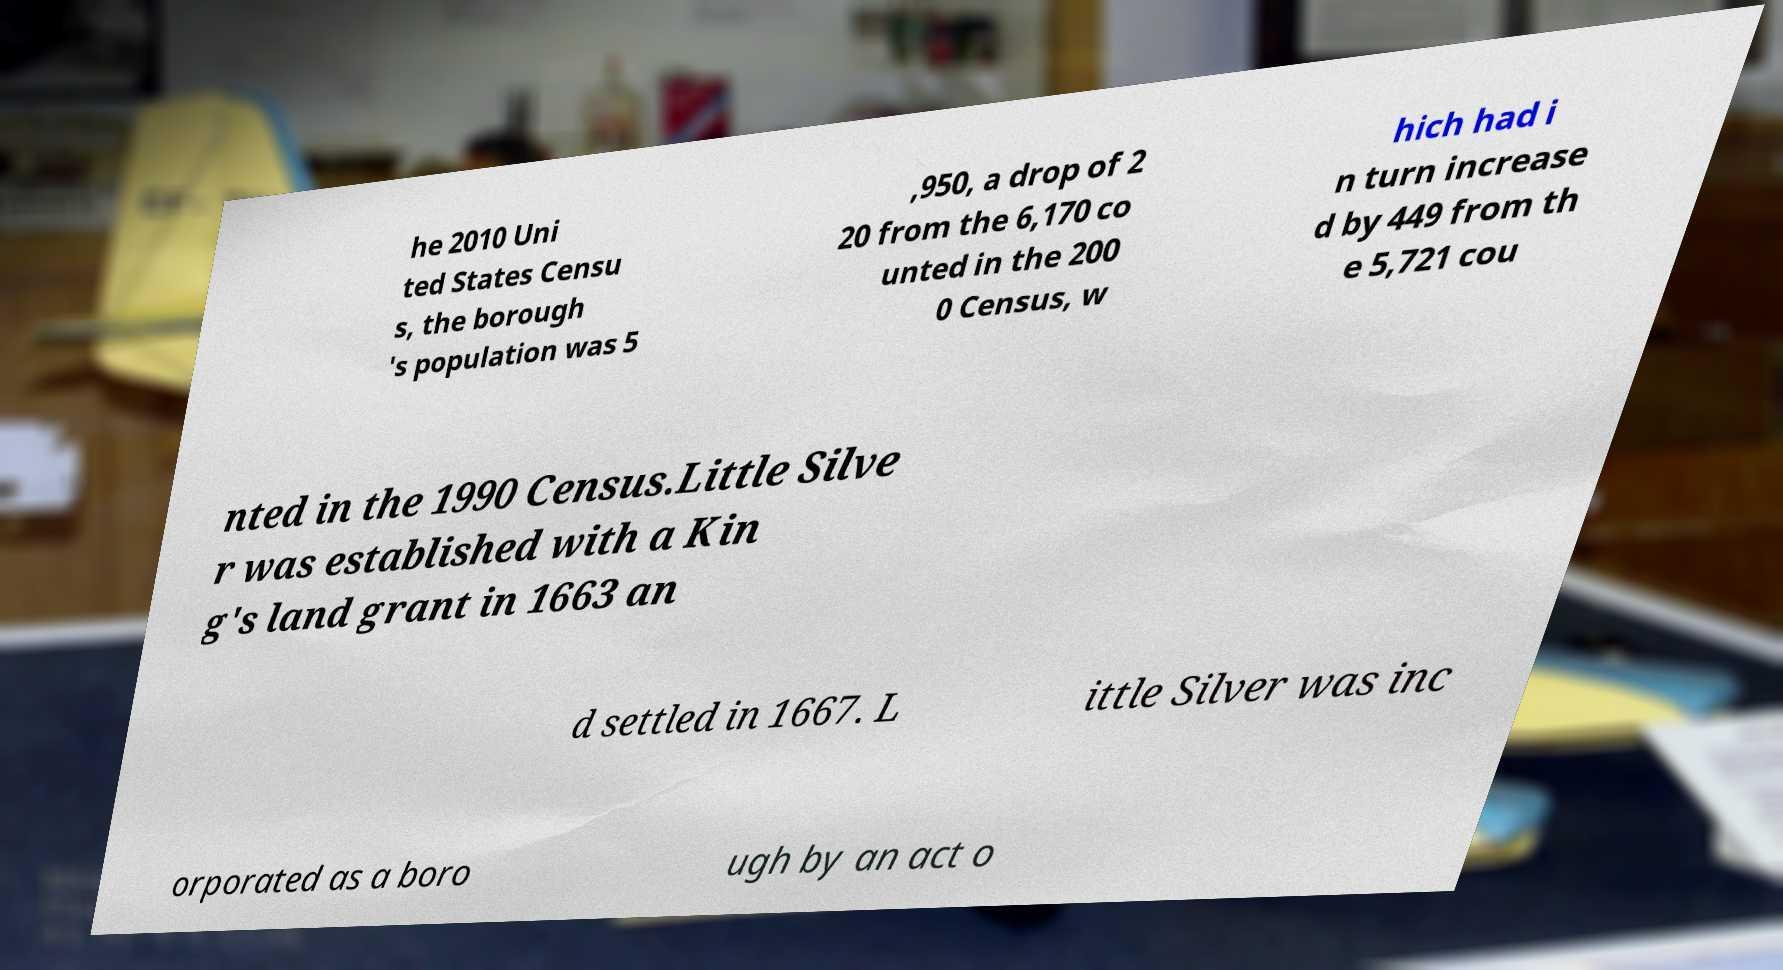For documentation purposes, I need the text within this image transcribed. Could you provide that? he 2010 Uni ted States Censu s, the borough 's population was 5 ,950, a drop of 2 20 from the 6,170 co unted in the 200 0 Census, w hich had i n turn increase d by 449 from th e 5,721 cou nted in the 1990 Census.Little Silve r was established with a Kin g's land grant in 1663 an d settled in 1667. L ittle Silver was inc orporated as a boro ugh by an act o 